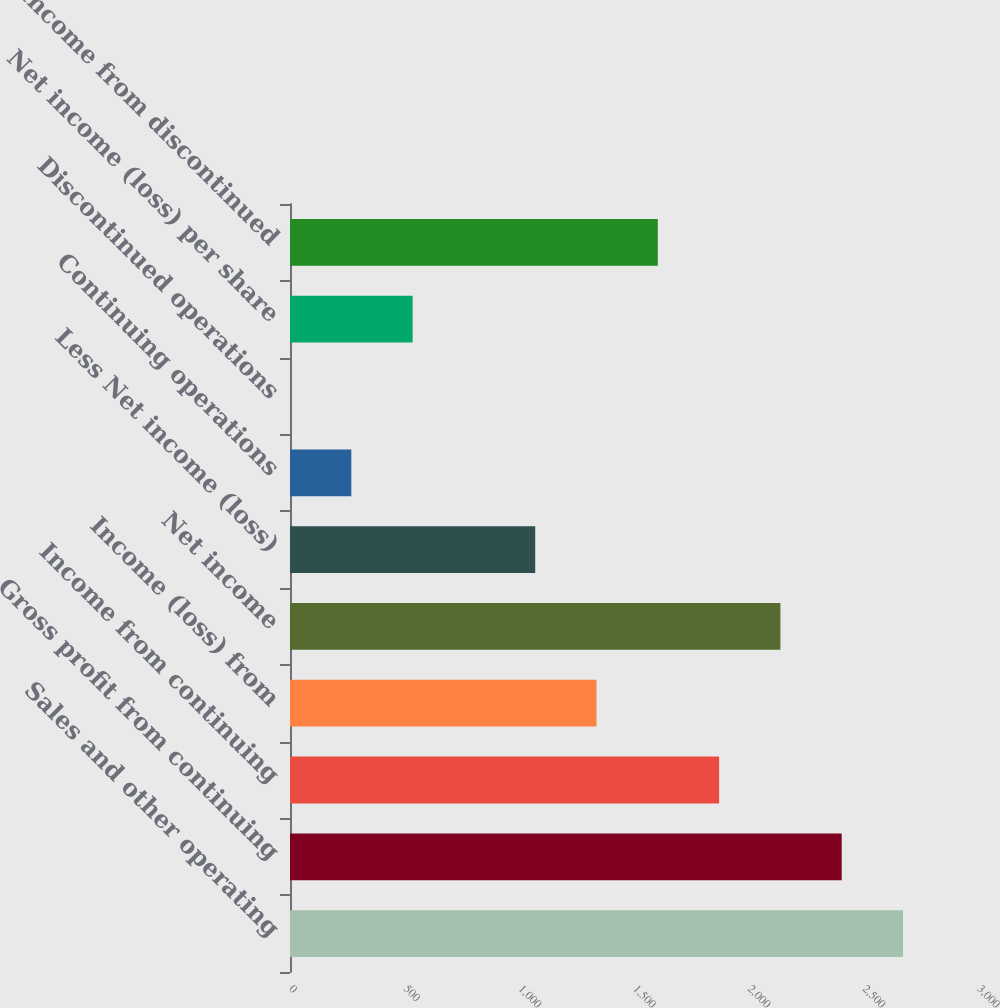Convert chart. <chart><loc_0><loc_0><loc_500><loc_500><bar_chart><fcel>Sales and other operating<fcel>Gross profit from continuing<fcel>Income from continuing<fcel>Income (loss) from<fcel>Net income<fcel>Less Net income (loss)<fcel>Continuing operations<fcel>Discontinued operations<fcel>Net income (loss) per share<fcel>Income from discontinued<nl><fcel>2673<fcel>2405.68<fcel>1871.1<fcel>1336.52<fcel>2138.39<fcel>1069.23<fcel>267.36<fcel>0.07<fcel>534.65<fcel>1603.81<nl></chart> 